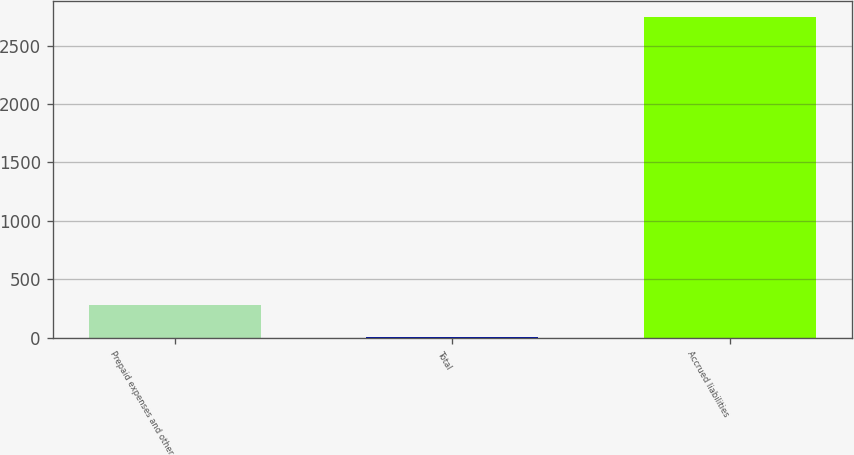Convert chart to OTSL. <chart><loc_0><loc_0><loc_500><loc_500><bar_chart><fcel>Prepaid expenses and other<fcel>Total<fcel>Accrued liabilities<nl><fcel>278.51<fcel>4.68<fcel>2743<nl></chart> 